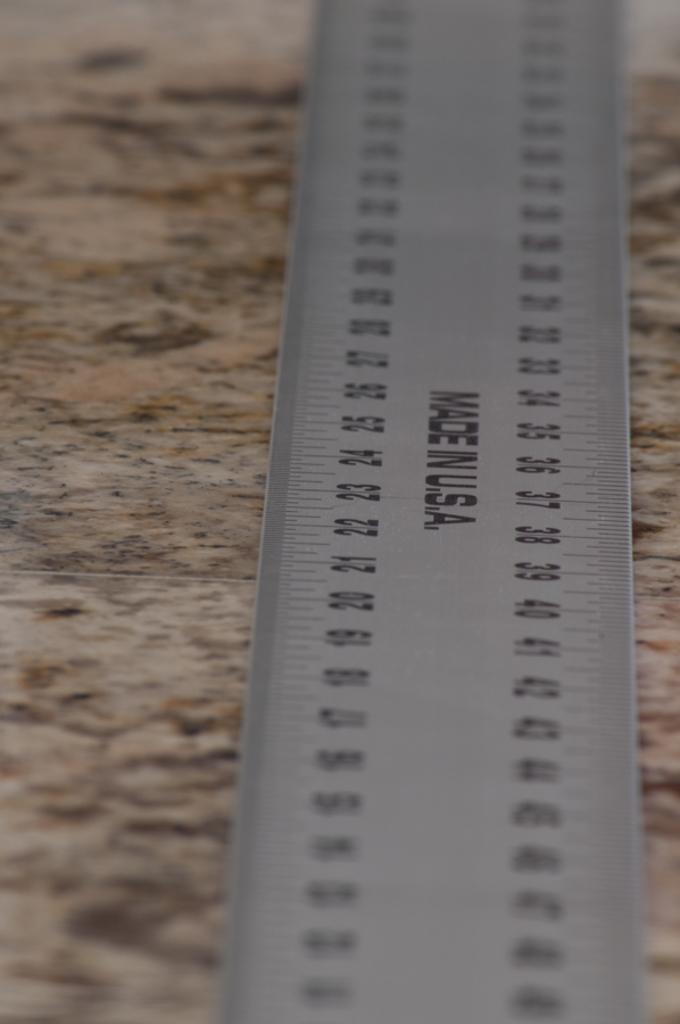Where is this rule made?
Make the answer very short. Usa. 